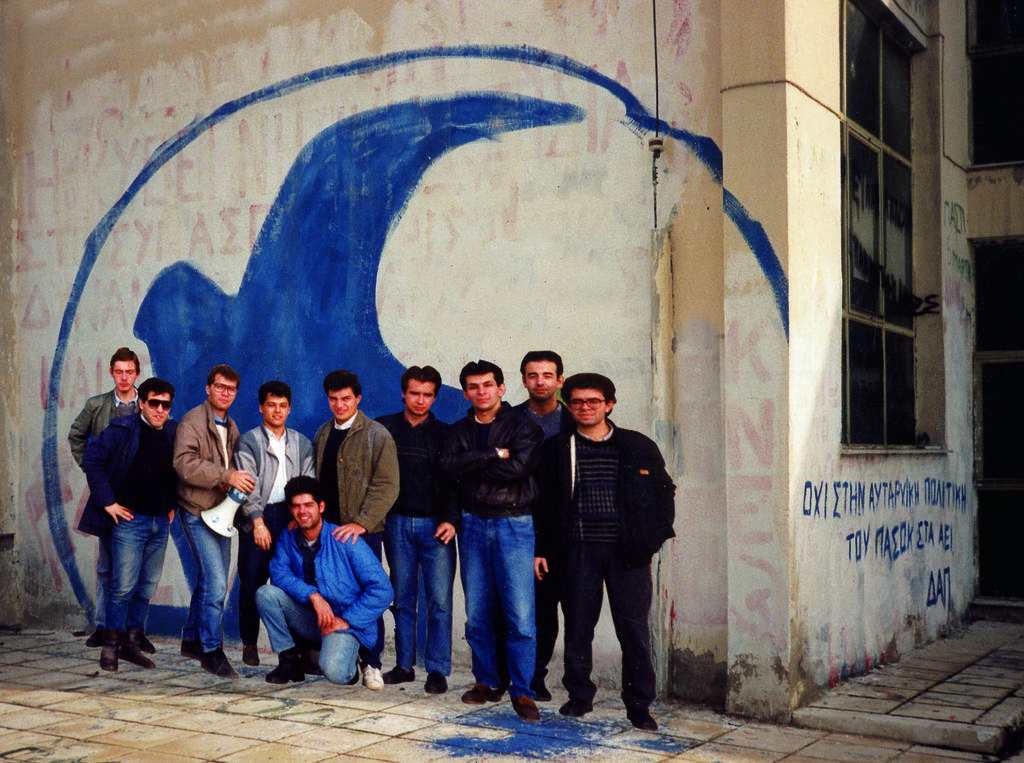Who or what can be seen in the image? There are people in the image. What is the primary feature of the landscape in the image? There is a path in the image. What can be seen in the distance in the image? There is a building in the background of the image. What is a notable feature of the building? The building has a window. What is present on the walls in the image? There is paint and text on the walls. How many circles can be seen in the image? There are no circles present in the image. What type of work are the people in the image doing? The provided facts do not indicate what type of work the people are doing, if any. 